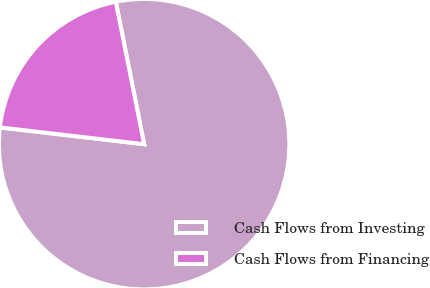Convert chart. <chart><loc_0><loc_0><loc_500><loc_500><pie_chart><fcel>Cash Flows from Investing<fcel>Cash Flows from Financing<nl><fcel>79.97%<fcel>20.03%<nl></chart> 